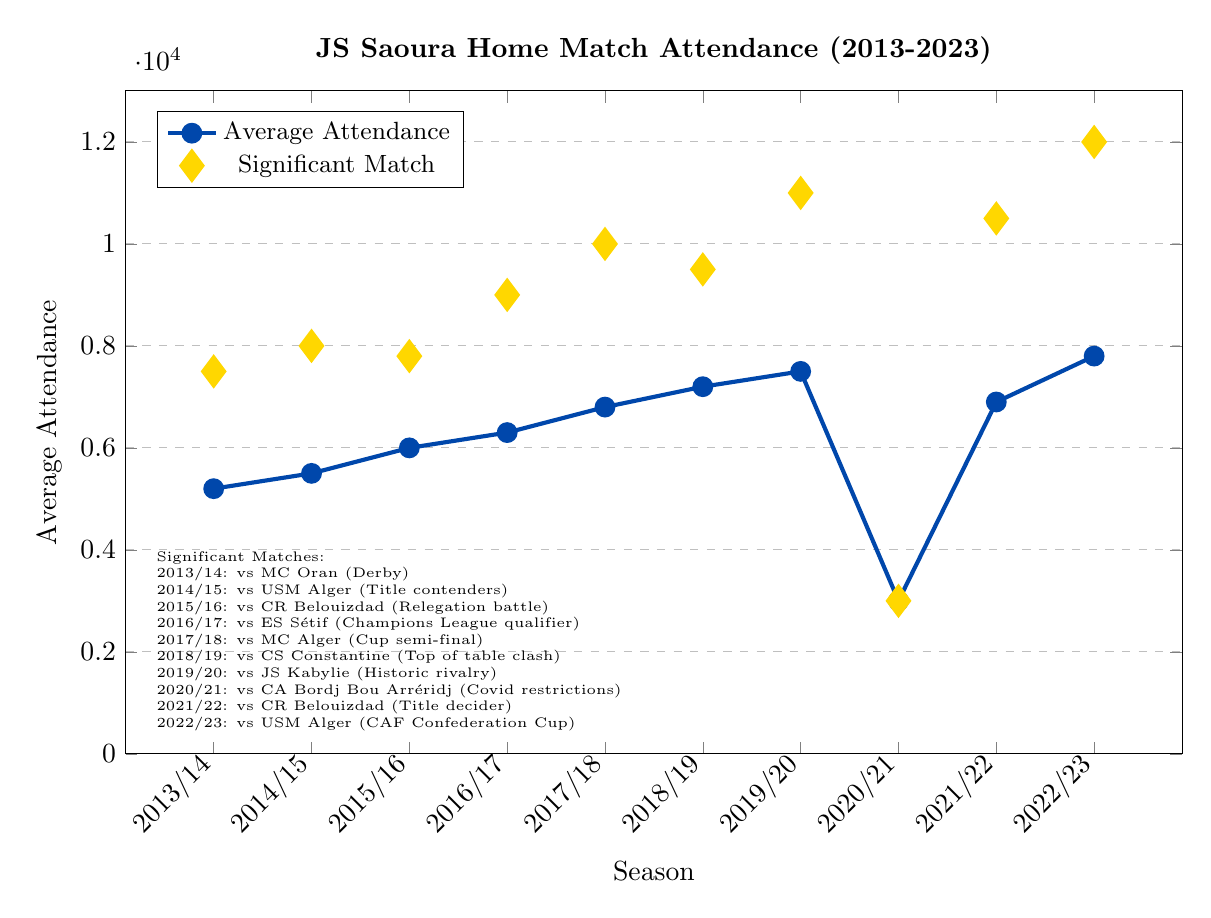What was the overall trend in average attendance for JS Saoura's home matches from 2013 to 2023? The overall trend shows a gradual increase in average attendance from 2013/14 (5200) to 2019/20 (7500) before a significant drop in 2020/21 (3000) due to Covid restrictions. Attendance quickly recovered in the subsequent seasons, reaching 7800 in 2022/23.
Answer: Increase with a dip in 2020/21 Which season had the highest average attendance? Observing the plot, the highest average attendance occurred in the 2022/23 season, with a value of 7800.
Answer: 2022/23 What was the significant match with the highest attendance figure? The significant match with the highest attendance is noted in the 2022/23 season against USM Alger, with an attendance of 12000.
Answer: USM Alger, 12000 How does the average attendance for the 2020/21 season compare to the prior season (2019/20)? The average attendance for 2020/21 (3000) was significantly lower compared to 2019/20 (7500) due to Covid restrictions.
Answer: Much lower Between which two consecutive seasons did the average attendance experience the most significant increase? The largest increase in average attendance can be observed between the 2020/21 (3000) and 2021/22 (6900) seasons, with an increase of 3900.
Answer: Between 2020/21 and 2021/22 How many seasons had an average attendance higher than 6000? By inspecting the plot, seasons 2015/16, 2016/17, 2017/18, 2018/19, 2019/20, 2021/22, and 2022/23 had average attendances higher than 6000. So, there are 7 seasons in total.
Answer: 7 What was the average difference in attendance between significant matches and average attendance for each season? The differences for each season are: 2013/14: 2300, 2014/15: 2500, 2015/16: 1800, 2016/17: 2700, 2017/18: 3200, 2018/19: 2300, 2019/20: 3500, 2020/21: 0, 2021/22: 3600, 2022/23: 4200. The average of these differences is (2300+2500+1800+2700+3200+2300+3500+0+3600+4200)/10 = 2610.
Answer: 2610 Which significant match had an attendance equal to the average attendance that season? Observing the plot, the only significant match with attendance equal to the average attendance is in the 2020/21 season against CA Bordj Bou Arréridj, with an attendance of 3000.
Answer: CA Bordj Bou Arréridj How did the significant match attendance trend from 2013 to 2023? The plot shows an overall increasing trend in significant match attendance from 7500 in 2013/14 to 12000 in 2022/23, with a notable drop to 3000 in 2020/21 due to Covid restrictions.
Answer: Increasing with a dip in 2020/21 Which color represents the significant match attendance on the plot? The plot's legend shows the significant match attendance represented with yellow diamond marks.
Answer: Yellow 